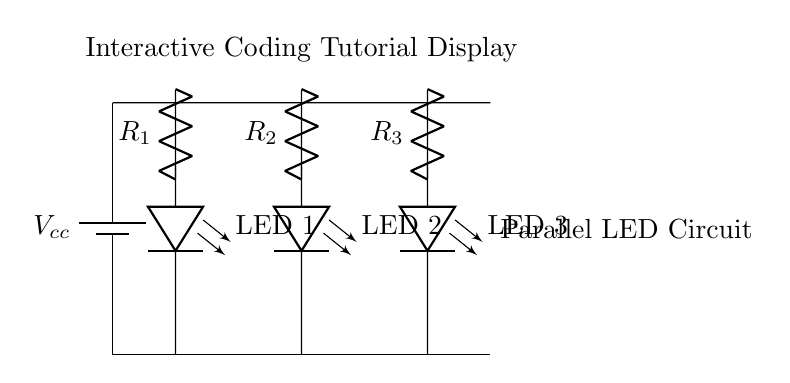what type of circuit is shown? The circuit diagram depicts a parallel circuit, as all components (LEDs) are connected alongside each other rather than in a sequence.
Answer: parallel how many LEDs are there in the circuit? The circuit shows three LEDs connected in parallel.
Answer: three what is the role of the resistors in this circuit? The resistors (R1, R2, R3) limit the current flowing through each LED, ensuring they operate within their specified current ratings to prevent damage.
Answer: limit current if one LED fails, what happens to the others? In a parallel circuit, if one LED fails, the others remain operational because they have separate paths for current, so the circuit continues to work.
Answer: remain operational what is the function of the power supply? The power supply provides the necessary voltage (Vcc) to power all components in the circuit, supplying energy necessary for the LEDs to illuminate.
Answer: provide voltage what is the total voltage across each LED? Each LED experiences the same voltage as the source voltage (Vcc) owing to its parallel connection.
Answer: Vcc why are the resistors placed above the LEDs? The resistors are placed above the LEDs to ensure that they are positioned in series with the LEDs to regulate current flow before it reaches them, thus providing effective current limiting to each LED.
Answer: to limit current flow 